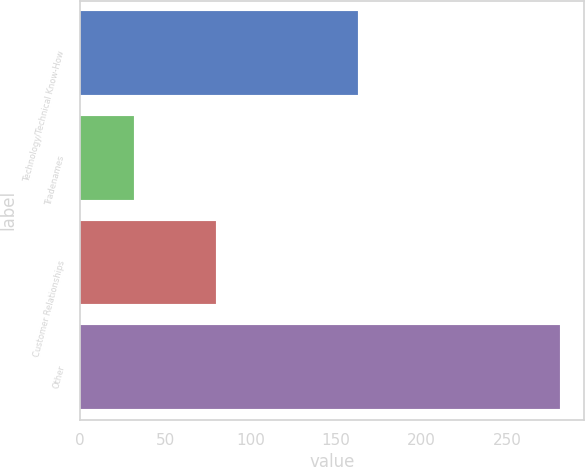Convert chart to OTSL. <chart><loc_0><loc_0><loc_500><loc_500><bar_chart><fcel>Technology/Technical Know-How<fcel>Tradenames<fcel>Customer Relationships<fcel>Other<nl><fcel>163<fcel>32<fcel>80<fcel>281<nl></chart> 